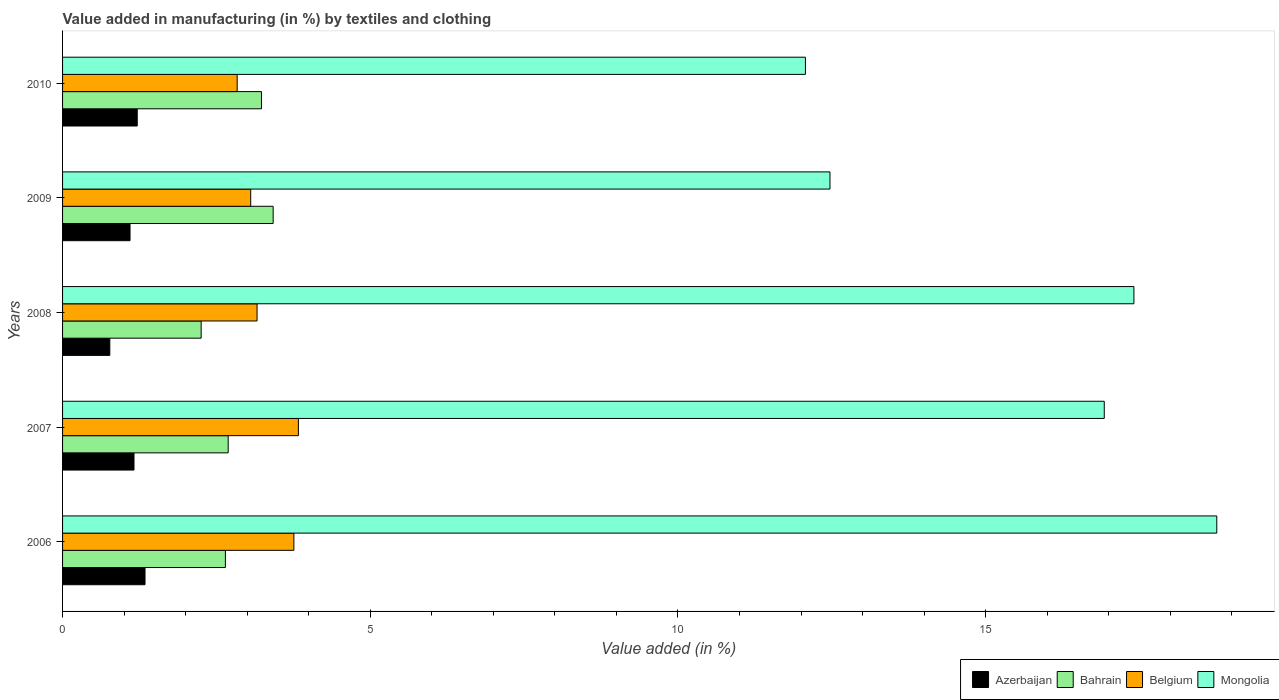How many different coloured bars are there?
Make the answer very short. 4. Are the number of bars on each tick of the Y-axis equal?
Provide a short and direct response. Yes. How many bars are there on the 3rd tick from the top?
Offer a very short reply. 4. How many bars are there on the 3rd tick from the bottom?
Provide a succinct answer. 4. In how many cases, is the number of bars for a given year not equal to the number of legend labels?
Your answer should be compact. 0. What is the percentage of value added in manufacturing by textiles and clothing in Mongolia in 2009?
Offer a very short reply. 12.47. Across all years, what is the maximum percentage of value added in manufacturing by textiles and clothing in Azerbaijan?
Keep it short and to the point. 1.34. Across all years, what is the minimum percentage of value added in manufacturing by textiles and clothing in Bahrain?
Offer a terse response. 2.25. What is the total percentage of value added in manufacturing by textiles and clothing in Mongolia in the graph?
Make the answer very short. 77.63. What is the difference between the percentage of value added in manufacturing by textiles and clothing in Bahrain in 2008 and that in 2010?
Offer a terse response. -0.98. What is the difference between the percentage of value added in manufacturing by textiles and clothing in Mongolia in 2006 and the percentage of value added in manufacturing by textiles and clothing in Bahrain in 2009?
Offer a very short reply. 15.33. What is the average percentage of value added in manufacturing by textiles and clothing in Mongolia per year?
Ensure brevity in your answer.  15.53. In the year 2008, what is the difference between the percentage of value added in manufacturing by textiles and clothing in Mongolia and percentage of value added in manufacturing by textiles and clothing in Belgium?
Make the answer very short. 14.25. What is the ratio of the percentage of value added in manufacturing by textiles and clothing in Belgium in 2007 to that in 2010?
Provide a short and direct response. 1.35. Is the percentage of value added in manufacturing by textiles and clothing in Bahrain in 2007 less than that in 2008?
Your answer should be very brief. No. What is the difference between the highest and the second highest percentage of value added in manufacturing by textiles and clothing in Bahrain?
Your answer should be very brief. 0.19. What is the difference between the highest and the lowest percentage of value added in manufacturing by textiles and clothing in Azerbaijan?
Keep it short and to the point. 0.57. In how many years, is the percentage of value added in manufacturing by textiles and clothing in Belgium greater than the average percentage of value added in manufacturing by textiles and clothing in Belgium taken over all years?
Your answer should be very brief. 2. Is it the case that in every year, the sum of the percentage of value added in manufacturing by textiles and clothing in Azerbaijan and percentage of value added in manufacturing by textiles and clothing in Mongolia is greater than the sum of percentage of value added in manufacturing by textiles and clothing in Bahrain and percentage of value added in manufacturing by textiles and clothing in Belgium?
Ensure brevity in your answer.  Yes. What does the 4th bar from the top in 2010 represents?
Your response must be concise. Azerbaijan. What does the 1st bar from the bottom in 2006 represents?
Keep it short and to the point. Azerbaijan. How many bars are there?
Provide a short and direct response. 20. Are all the bars in the graph horizontal?
Keep it short and to the point. Yes. How many years are there in the graph?
Offer a very short reply. 5. Are the values on the major ticks of X-axis written in scientific E-notation?
Your answer should be compact. No. Does the graph contain grids?
Keep it short and to the point. No. Where does the legend appear in the graph?
Ensure brevity in your answer.  Bottom right. What is the title of the graph?
Your response must be concise. Value added in manufacturing (in %) by textiles and clothing. What is the label or title of the X-axis?
Offer a very short reply. Value added (in %). What is the Value added (in %) in Azerbaijan in 2006?
Provide a succinct answer. 1.34. What is the Value added (in %) of Bahrain in 2006?
Your answer should be compact. 2.65. What is the Value added (in %) in Belgium in 2006?
Ensure brevity in your answer.  3.76. What is the Value added (in %) in Mongolia in 2006?
Provide a short and direct response. 18.76. What is the Value added (in %) in Azerbaijan in 2007?
Provide a short and direct response. 1.16. What is the Value added (in %) of Bahrain in 2007?
Provide a short and direct response. 2.69. What is the Value added (in %) in Belgium in 2007?
Make the answer very short. 3.83. What is the Value added (in %) of Mongolia in 2007?
Offer a very short reply. 16.93. What is the Value added (in %) in Azerbaijan in 2008?
Your response must be concise. 0.77. What is the Value added (in %) in Bahrain in 2008?
Your answer should be compact. 2.25. What is the Value added (in %) in Belgium in 2008?
Your answer should be compact. 3.16. What is the Value added (in %) in Mongolia in 2008?
Offer a terse response. 17.41. What is the Value added (in %) in Azerbaijan in 2009?
Your response must be concise. 1.1. What is the Value added (in %) of Bahrain in 2009?
Provide a succinct answer. 3.42. What is the Value added (in %) in Belgium in 2009?
Offer a terse response. 3.06. What is the Value added (in %) in Mongolia in 2009?
Your answer should be compact. 12.47. What is the Value added (in %) in Azerbaijan in 2010?
Make the answer very short. 1.21. What is the Value added (in %) of Bahrain in 2010?
Offer a very short reply. 3.23. What is the Value added (in %) of Belgium in 2010?
Give a very brief answer. 2.84. What is the Value added (in %) of Mongolia in 2010?
Your answer should be compact. 12.07. Across all years, what is the maximum Value added (in %) in Azerbaijan?
Provide a succinct answer. 1.34. Across all years, what is the maximum Value added (in %) of Bahrain?
Your answer should be very brief. 3.42. Across all years, what is the maximum Value added (in %) in Belgium?
Provide a short and direct response. 3.83. Across all years, what is the maximum Value added (in %) of Mongolia?
Your answer should be compact. 18.76. Across all years, what is the minimum Value added (in %) in Azerbaijan?
Offer a terse response. 0.77. Across all years, what is the minimum Value added (in %) in Bahrain?
Provide a succinct answer. 2.25. Across all years, what is the minimum Value added (in %) of Belgium?
Offer a very short reply. 2.84. Across all years, what is the minimum Value added (in %) of Mongolia?
Provide a short and direct response. 12.07. What is the total Value added (in %) of Azerbaijan in the graph?
Provide a succinct answer. 5.58. What is the total Value added (in %) in Bahrain in the graph?
Keep it short and to the point. 14.24. What is the total Value added (in %) of Belgium in the graph?
Provide a succinct answer. 16.65. What is the total Value added (in %) of Mongolia in the graph?
Offer a terse response. 77.63. What is the difference between the Value added (in %) of Azerbaijan in 2006 and that in 2007?
Offer a very short reply. 0.18. What is the difference between the Value added (in %) of Bahrain in 2006 and that in 2007?
Provide a short and direct response. -0.05. What is the difference between the Value added (in %) in Belgium in 2006 and that in 2007?
Provide a short and direct response. -0.07. What is the difference between the Value added (in %) in Mongolia in 2006 and that in 2007?
Your answer should be compact. 1.83. What is the difference between the Value added (in %) in Azerbaijan in 2006 and that in 2008?
Your response must be concise. 0.57. What is the difference between the Value added (in %) in Bahrain in 2006 and that in 2008?
Your answer should be compact. 0.39. What is the difference between the Value added (in %) of Belgium in 2006 and that in 2008?
Your answer should be compact. 0.6. What is the difference between the Value added (in %) in Mongolia in 2006 and that in 2008?
Provide a succinct answer. 1.35. What is the difference between the Value added (in %) in Azerbaijan in 2006 and that in 2009?
Ensure brevity in your answer.  0.24. What is the difference between the Value added (in %) of Bahrain in 2006 and that in 2009?
Your answer should be very brief. -0.78. What is the difference between the Value added (in %) in Belgium in 2006 and that in 2009?
Your answer should be very brief. 0.7. What is the difference between the Value added (in %) in Mongolia in 2006 and that in 2009?
Give a very brief answer. 6.29. What is the difference between the Value added (in %) of Azerbaijan in 2006 and that in 2010?
Give a very brief answer. 0.13. What is the difference between the Value added (in %) in Bahrain in 2006 and that in 2010?
Provide a succinct answer. -0.59. What is the difference between the Value added (in %) in Belgium in 2006 and that in 2010?
Provide a succinct answer. 0.92. What is the difference between the Value added (in %) of Mongolia in 2006 and that in 2010?
Your answer should be compact. 6.68. What is the difference between the Value added (in %) of Azerbaijan in 2007 and that in 2008?
Give a very brief answer. 0.39. What is the difference between the Value added (in %) of Bahrain in 2007 and that in 2008?
Provide a short and direct response. 0.44. What is the difference between the Value added (in %) in Belgium in 2007 and that in 2008?
Give a very brief answer. 0.67. What is the difference between the Value added (in %) of Mongolia in 2007 and that in 2008?
Your response must be concise. -0.48. What is the difference between the Value added (in %) of Azerbaijan in 2007 and that in 2009?
Provide a succinct answer. 0.06. What is the difference between the Value added (in %) in Bahrain in 2007 and that in 2009?
Your answer should be very brief. -0.73. What is the difference between the Value added (in %) in Belgium in 2007 and that in 2009?
Offer a terse response. 0.77. What is the difference between the Value added (in %) in Mongolia in 2007 and that in 2009?
Your answer should be very brief. 4.46. What is the difference between the Value added (in %) of Azerbaijan in 2007 and that in 2010?
Give a very brief answer. -0.05. What is the difference between the Value added (in %) of Bahrain in 2007 and that in 2010?
Keep it short and to the point. -0.54. What is the difference between the Value added (in %) of Mongolia in 2007 and that in 2010?
Provide a short and direct response. 4.86. What is the difference between the Value added (in %) in Azerbaijan in 2008 and that in 2009?
Give a very brief answer. -0.33. What is the difference between the Value added (in %) in Bahrain in 2008 and that in 2009?
Your response must be concise. -1.17. What is the difference between the Value added (in %) of Belgium in 2008 and that in 2009?
Offer a very short reply. 0.1. What is the difference between the Value added (in %) of Mongolia in 2008 and that in 2009?
Offer a very short reply. 4.94. What is the difference between the Value added (in %) in Azerbaijan in 2008 and that in 2010?
Make the answer very short. -0.45. What is the difference between the Value added (in %) in Bahrain in 2008 and that in 2010?
Provide a succinct answer. -0.98. What is the difference between the Value added (in %) in Belgium in 2008 and that in 2010?
Provide a succinct answer. 0.32. What is the difference between the Value added (in %) of Mongolia in 2008 and that in 2010?
Offer a very short reply. 5.34. What is the difference between the Value added (in %) of Azerbaijan in 2009 and that in 2010?
Provide a succinct answer. -0.12. What is the difference between the Value added (in %) in Bahrain in 2009 and that in 2010?
Your answer should be very brief. 0.19. What is the difference between the Value added (in %) in Belgium in 2009 and that in 2010?
Offer a terse response. 0.22. What is the difference between the Value added (in %) of Mongolia in 2009 and that in 2010?
Offer a terse response. 0.4. What is the difference between the Value added (in %) of Azerbaijan in 2006 and the Value added (in %) of Bahrain in 2007?
Keep it short and to the point. -1.35. What is the difference between the Value added (in %) of Azerbaijan in 2006 and the Value added (in %) of Belgium in 2007?
Offer a very short reply. -2.49. What is the difference between the Value added (in %) of Azerbaijan in 2006 and the Value added (in %) of Mongolia in 2007?
Your answer should be compact. -15.59. What is the difference between the Value added (in %) in Bahrain in 2006 and the Value added (in %) in Belgium in 2007?
Ensure brevity in your answer.  -1.19. What is the difference between the Value added (in %) of Bahrain in 2006 and the Value added (in %) of Mongolia in 2007?
Provide a succinct answer. -14.28. What is the difference between the Value added (in %) in Belgium in 2006 and the Value added (in %) in Mongolia in 2007?
Give a very brief answer. -13.17. What is the difference between the Value added (in %) in Azerbaijan in 2006 and the Value added (in %) in Bahrain in 2008?
Make the answer very short. -0.91. What is the difference between the Value added (in %) of Azerbaijan in 2006 and the Value added (in %) of Belgium in 2008?
Your answer should be very brief. -1.82. What is the difference between the Value added (in %) of Azerbaijan in 2006 and the Value added (in %) of Mongolia in 2008?
Your response must be concise. -16.07. What is the difference between the Value added (in %) in Bahrain in 2006 and the Value added (in %) in Belgium in 2008?
Provide a succinct answer. -0.51. What is the difference between the Value added (in %) of Bahrain in 2006 and the Value added (in %) of Mongolia in 2008?
Your response must be concise. -14.76. What is the difference between the Value added (in %) of Belgium in 2006 and the Value added (in %) of Mongolia in 2008?
Your response must be concise. -13.65. What is the difference between the Value added (in %) in Azerbaijan in 2006 and the Value added (in %) in Bahrain in 2009?
Provide a short and direct response. -2.08. What is the difference between the Value added (in %) in Azerbaijan in 2006 and the Value added (in %) in Belgium in 2009?
Offer a terse response. -1.72. What is the difference between the Value added (in %) of Azerbaijan in 2006 and the Value added (in %) of Mongolia in 2009?
Keep it short and to the point. -11.13. What is the difference between the Value added (in %) of Bahrain in 2006 and the Value added (in %) of Belgium in 2009?
Offer a very short reply. -0.41. What is the difference between the Value added (in %) of Bahrain in 2006 and the Value added (in %) of Mongolia in 2009?
Ensure brevity in your answer.  -9.82. What is the difference between the Value added (in %) of Belgium in 2006 and the Value added (in %) of Mongolia in 2009?
Make the answer very short. -8.71. What is the difference between the Value added (in %) in Azerbaijan in 2006 and the Value added (in %) in Bahrain in 2010?
Your answer should be very brief. -1.89. What is the difference between the Value added (in %) of Azerbaijan in 2006 and the Value added (in %) of Belgium in 2010?
Provide a short and direct response. -1.5. What is the difference between the Value added (in %) of Azerbaijan in 2006 and the Value added (in %) of Mongolia in 2010?
Your answer should be very brief. -10.73. What is the difference between the Value added (in %) in Bahrain in 2006 and the Value added (in %) in Belgium in 2010?
Your response must be concise. -0.19. What is the difference between the Value added (in %) in Bahrain in 2006 and the Value added (in %) in Mongolia in 2010?
Give a very brief answer. -9.43. What is the difference between the Value added (in %) in Belgium in 2006 and the Value added (in %) in Mongolia in 2010?
Make the answer very short. -8.31. What is the difference between the Value added (in %) in Azerbaijan in 2007 and the Value added (in %) in Bahrain in 2008?
Ensure brevity in your answer.  -1.09. What is the difference between the Value added (in %) of Azerbaijan in 2007 and the Value added (in %) of Belgium in 2008?
Your answer should be compact. -2. What is the difference between the Value added (in %) in Azerbaijan in 2007 and the Value added (in %) in Mongolia in 2008?
Your answer should be compact. -16.25. What is the difference between the Value added (in %) of Bahrain in 2007 and the Value added (in %) of Belgium in 2008?
Provide a short and direct response. -0.47. What is the difference between the Value added (in %) in Bahrain in 2007 and the Value added (in %) in Mongolia in 2008?
Keep it short and to the point. -14.72. What is the difference between the Value added (in %) in Belgium in 2007 and the Value added (in %) in Mongolia in 2008?
Your answer should be compact. -13.58. What is the difference between the Value added (in %) of Azerbaijan in 2007 and the Value added (in %) of Bahrain in 2009?
Keep it short and to the point. -2.26. What is the difference between the Value added (in %) of Azerbaijan in 2007 and the Value added (in %) of Belgium in 2009?
Your answer should be compact. -1.9. What is the difference between the Value added (in %) in Azerbaijan in 2007 and the Value added (in %) in Mongolia in 2009?
Offer a terse response. -11.31. What is the difference between the Value added (in %) of Bahrain in 2007 and the Value added (in %) of Belgium in 2009?
Your answer should be compact. -0.37. What is the difference between the Value added (in %) of Bahrain in 2007 and the Value added (in %) of Mongolia in 2009?
Your answer should be very brief. -9.78. What is the difference between the Value added (in %) of Belgium in 2007 and the Value added (in %) of Mongolia in 2009?
Your answer should be very brief. -8.64. What is the difference between the Value added (in %) in Azerbaijan in 2007 and the Value added (in %) in Bahrain in 2010?
Your answer should be compact. -2.07. What is the difference between the Value added (in %) in Azerbaijan in 2007 and the Value added (in %) in Belgium in 2010?
Your answer should be compact. -1.68. What is the difference between the Value added (in %) in Azerbaijan in 2007 and the Value added (in %) in Mongolia in 2010?
Ensure brevity in your answer.  -10.91. What is the difference between the Value added (in %) of Bahrain in 2007 and the Value added (in %) of Belgium in 2010?
Provide a succinct answer. -0.15. What is the difference between the Value added (in %) in Bahrain in 2007 and the Value added (in %) in Mongolia in 2010?
Provide a succinct answer. -9.38. What is the difference between the Value added (in %) of Belgium in 2007 and the Value added (in %) of Mongolia in 2010?
Your answer should be very brief. -8.24. What is the difference between the Value added (in %) of Azerbaijan in 2008 and the Value added (in %) of Bahrain in 2009?
Give a very brief answer. -2.65. What is the difference between the Value added (in %) of Azerbaijan in 2008 and the Value added (in %) of Belgium in 2009?
Provide a succinct answer. -2.29. What is the difference between the Value added (in %) in Azerbaijan in 2008 and the Value added (in %) in Mongolia in 2009?
Ensure brevity in your answer.  -11.7. What is the difference between the Value added (in %) of Bahrain in 2008 and the Value added (in %) of Belgium in 2009?
Provide a short and direct response. -0.81. What is the difference between the Value added (in %) in Bahrain in 2008 and the Value added (in %) in Mongolia in 2009?
Make the answer very short. -10.22. What is the difference between the Value added (in %) of Belgium in 2008 and the Value added (in %) of Mongolia in 2009?
Offer a terse response. -9.31. What is the difference between the Value added (in %) of Azerbaijan in 2008 and the Value added (in %) of Bahrain in 2010?
Provide a short and direct response. -2.46. What is the difference between the Value added (in %) in Azerbaijan in 2008 and the Value added (in %) in Belgium in 2010?
Offer a very short reply. -2.07. What is the difference between the Value added (in %) in Azerbaijan in 2008 and the Value added (in %) in Mongolia in 2010?
Make the answer very short. -11.3. What is the difference between the Value added (in %) in Bahrain in 2008 and the Value added (in %) in Belgium in 2010?
Offer a terse response. -0.59. What is the difference between the Value added (in %) of Bahrain in 2008 and the Value added (in %) of Mongolia in 2010?
Give a very brief answer. -9.82. What is the difference between the Value added (in %) in Belgium in 2008 and the Value added (in %) in Mongolia in 2010?
Provide a short and direct response. -8.91. What is the difference between the Value added (in %) in Azerbaijan in 2009 and the Value added (in %) in Bahrain in 2010?
Give a very brief answer. -2.14. What is the difference between the Value added (in %) of Azerbaijan in 2009 and the Value added (in %) of Belgium in 2010?
Keep it short and to the point. -1.74. What is the difference between the Value added (in %) in Azerbaijan in 2009 and the Value added (in %) in Mongolia in 2010?
Your answer should be very brief. -10.97. What is the difference between the Value added (in %) in Bahrain in 2009 and the Value added (in %) in Belgium in 2010?
Ensure brevity in your answer.  0.58. What is the difference between the Value added (in %) in Bahrain in 2009 and the Value added (in %) in Mongolia in 2010?
Your answer should be compact. -8.65. What is the difference between the Value added (in %) of Belgium in 2009 and the Value added (in %) of Mongolia in 2010?
Keep it short and to the point. -9.01. What is the average Value added (in %) of Azerbaijan per year?
Offer a very short reply. 1.12. What is the average Value added (in %) in Bahrain per year?
Your response must be concise. 2.85. What is the average Value added (in %) in Belgium per year?
Your answer should be very brief. 3.33. What is the average Value added (in %) in Mongolia per year?
Ensure brevity in your answer.  15.53. In the year 2006, what is the difference between the Value added (in %) of Azerbaijan and Value added (in %) of Bahrain?
Ensure brevity in your answer.  -1.31. In the year 2006, what is the difference between the Value added (in %) in Azerbaijan and Value added (in %) in Belgium?
Provide a short and direct response. -2.42. In the year 2006, what is the difference between the Value added (in %) in Azerbaijan and Value added (in %) in Mongolia?
Your answer should be compact. -17.42. In the year 2006, what is the difference between the Value added (in %) in Bahrain and Value added (in %) in Belgium?
Ensure brevity in your answer.  -1.11. In the year 2006, what is the difference between the Value added (in %) of Bahrain and Value added (in %) of Mongolia?
Offer a terse response. -16.11. In the year 2006, what is the difference between the Value added (in %) in Belgium and Value added (in %) in Mongolia?
Give a very brief answer. -15. In the year 2007, what is the difference between the Value added (in %) in Azerbaijan and Value added (in %) in Bahrain?
Offer a very short reply. -1.53. In the year 2007, what is the difference between the Value added (in %) in Azerbaijan and Value added (in %) in Belgium?
Make the answer very short. -2.67. In the year 2007, what is the difference between the Value added (in %) in Azerbaijan and Value added (in %) in Mongolia?
Ensure brevity in your answer.  -15.77. In the year 2007, what is the difference between the Value added (in %) in Bahrain and Value added (in %) in Belgium?
Offer a very short reply. -1.14. In the year 2007, what is the difference between the Value added (in %) of Bahrain and Value added (in %) of Mongolia?
Offer a very short reply. -14.24. In the year 2007, what is the difference between the Value added (in %) of Belgium and Value added (in %) of Mongolia?
Make the answer very short. -13.1. In the year 2008, what is the difference between the Value added (in %) of Azerbaijan and Value added (in %) of Bahrain?
Provide a short and direct response. -1.48. In the year 2008, what is the difference between the Value added (in %) in Azerbaijan and Value added (in %) in Belgium?
Your response must be concise. -2.39. In the year 2008, what is the difference between the Value added (in %) of Azerbaijan and Value added (in %) of Mongolia?
Offer a very short reply. -16.64. In the year 2008, what is the difference between the Value added (in %) of Bahrain and Value added (in %) of Belgium?
Provide a succinct answer. -0.91. In the year 2008, what is the difference between the Value added (in %) of Bahrain and Value added (in %) of Mongolia?
Provide a succinct answer. -15.16. In the year 2008, what is the difference between the Value added (in %) in Belgium and Value added (in %) in Mongolia?
Keep it short and to the point. -14.25. In the year 2009, what is the difference between the Value added (in %) in Azerbaijan and Value added (in %) in Bahrain?
Keep it short and to the point. -2.33. In the year 2009, what is the difference between the Value added (in %) of Azerbaijan and Value added (in %) of Belgium?
Ensure brevity in your answer.  -1.96. In the year 2009, what is the difference between the Value added (in %) of Azerbaijan and Value added (in %) of Mongolia?
Your answer should be compact. -11.37. In the year 2009, what is the difference between the Value added (in %) in Bahrain and Value added (in %) in Belgium?
Offer a terse response. 0.36. In the year 2009, what is the difference between the Value added (in %) in Bahrain and Value added (in %) in Mongolia?
Give a very brief answer. -9.05. In the year 2009, what is the difference between the Value added (in %) in Belgium and Value added (in %) in Mongolia?
Offer a very short reply. -9.41. In the year 2010, what is the difference between the Value added (in %) of Azerbaijan and Value added (in %) of Bahrain?
Keep it short and to the point. -2.02. In the year 2010, what is the difference between the Value added (in %) in Azerbaijan and Value added (in %) in Belgium?
Provide a succinct answer. -1.62. In the year 2010, what is the difference between the Value added (in %) in Azerbaijan and Value added (in %) in Mongolia?
Ensure brevity in your answer.  -10.86. In the year 2010, what is the difference between the Value added (in %) in Bahrain and Value added (in %) in Belgium?
Keep it short and to the point. 0.39. In the year 2010, what is the difference between the Value added (in %) in Bahrain and Value added (in %) in Mongolia?
Your response must be concise. -8.84. In the year 2010, what is the difference between the Value added (in %) of Belgium and Value added (in %) of Mongolia?
Your answer should be compact. -9.23. What is the ratio of the Value added (in %) in Azerbaijan in 2006 to that in 2007?
Give a very brief answer. 1.15. What is the ratio of the Value added (in %) in Bahrain in 2006 to that in 2007?
Make the answer very short. 0.98. What is the ratio of the Value added (in %) of Belgium in 2006 to that in 2007?
Keep it short and to the point. 0.98. What is the ratio of the Value added (in %) in Mongolia in 2006 to that in 2007?
Ensure brevity in your answer.  1.11. What is the ratio of the Value added (in %) of Azerbaijan in 2006 to that in 2008?
Ensure brevity in your answer.  1.75. What is the ratio of the Value added (in %) of Bahrain in 2006 to that in 2008?
Keep it short and to the point. 1.17. What is the ratio of the Value added (in %) of Belgium in 2006 to that in 2008?
Provide a succinct answer. 1.19. What is the ratio of the Value added (in %) of Mongolia in 2006 to that in 2008?
Keep it short and to the point. 1.08. What is the ratio of the Value added (in %) in Azerbaijan in 2006 to that in 2009?
Ensure brevity in your answer.  1.22. What is the ratio of the Value added (in %) in Bahrain in 2006 to that in 2009?
Provide a succinct answer. 0.77. What is the ratio of the Value added (in %) in Belgium in 2006 to that in 2009?
Ensure brevity in your answer.  1.23. What is the ratio of the Value added (in %) in Mongolia in 2006 to that in 2009?
Provide a short and direct response. 1.5. What is the ratio of the Value added (in %) of Azerbaijan in 2006 to that in 2010?
Your answer should be very brief. 1.1. What is the ratio of the Value added (in %) in Bahrain in 2006 to that in 2010?
Keep it short and to the point. 0.82. What is the ratio of the Value added (in %) in Belgium in 2006 to that in 2010?
Offer a terse response. 1.32. What is the ratio of the Value added (in %) of Mongolia in 2006 to that in 2010?
Provide a succinct answer. 1.55. What is the ratio of the Value added (in %) of Azerbaijan in 2007 to that in 2008?
Provide a succinct answer. 1.51. What is the ratio of the Value added (in %) in Bahrain in 2007 to that in 2008?
Provide a succinct answer. 1.2. What is the ratio of the Value added (in %) of Belgium in 2007 to that in 2008?
Offer a terse response. 1.21. What is the ratio of the Value added (in %) of Mongolia in 2007 to that in 2008?
Your response must be concise. 0.97. What is the ratio of the Value added (in %) in Azerbaijan in 2007 to that in 2009?
Make the answer very short. 1.06. What is the ratio of the Value added (in %) of Bahrain in 2007 to that in 2009?
Your answer should be compact. 0.79. What is the ratio of the Value added (in %) in Belgium in 2007 to that in 2009?
Your response must be concise. 1.25. What is the ratio of the Value added (in %) in Mongolia in 2007 to that in 2009?
Ensure brevity in your answer.  1.36. What is the ratio of the Value added (in %) in Azerbaijan in 2007 to that in 2010?
Give a very brief answer. 0.96. What is the ratio of the Value added (in %) in Bahrain in 2007 to that in 2010?
Give a very brief answer. 0.83. What is the ratio of the Value added (in %) in Belgium in 2007 to that in 2010?
Ensure brevity in your answer.  1.35. What is the ratio of the Value added (in %) in Mongolia in 2007 to that in 2010?
Ensure brevity in your answer.  1.4. What is the ratio of the Value added (in %) in Azerbaijan in 2008 to that in 2009?
Offer a terse response. 0.7. What is the ratio of the Value added (in %) of Bahrain in 2008 to that in 2009?
Keep it short and to the point. 0.66. What is the ratio of the Value added (in %) of Belgium in 2008 to that in 2009?
Provide a short and direct response. 1.03. What is the ratio of the Value added (in %) of Mongolia in 2008 to that in 2009?
Offer a terse response. 1.4. What is the ratio of the Value added (in %) of Azerbaijan in 2008 to that in 2010?
Provide a short and direct response. 0.63. What is the ratio of the Value added (in %) of Bahrain in 2008 to that in 2010?
Keep it short and to the point. 0.7. What is the ratio of the Value added (in %) in Belgium in 2008 to that in 2010?
Your response must be concise. 1.11. What is the ratio of the Value added (in %) of Mongolia in 2008 to that in 2010?
Keep it short and to the point. 1.44. What is the ratio of the Value added (in %) of Azerbaijan in 2009 to that in 2010?
Provide a succinct answer. 0.9. What is the ratio of the Value added (in %) of Bahrain in 2009 to that in 2010?
Give a very brief answer. 1.06. What is the ratio of the Value added (in %) in Belgium in 2009 to that in 2010?
Ensure brevity in your answer.  1.08. What is the ratio of the Value added (in %) in Mongolia in 2009 to that in 2010?
Offer a very short reply. 1.03. What is the difference between the highest and the second highest Value added (in %) of Azerbaijan?
Give a very brief answer. 0.13. What is the difference between the highest and the second highest Value added (in %) of Bahrain?
Your answer should be very brief. 0.19. What is the difference between the highest and the second highest Value added (in %) of Belgium?
Make the answer very short. 0.07. What is the difference between the highest and the second highest Value added (in %) of Mongolia?
Provide a succinct answer. 1.35. What is the difference between the highest and the lowest Value added (in %) in Azerbaijan?
Give a very brief answer. 0.57. What is the difference between the highest and the lowest Value added (in %) in Bahrain?
Your response must be concise. 1.17. What is the difference between the highest and the lowest Value added (in %) of Belgium?
Give a very brief answer. 0.99. What is the difference between the highest and the lowest Value added (in %) of Mongolia?
Your answer should be very brief. 6.68. 